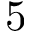Convert formula to latex. <formula><loc_0><loc_0><loc_500><loc_500>5</formula> 